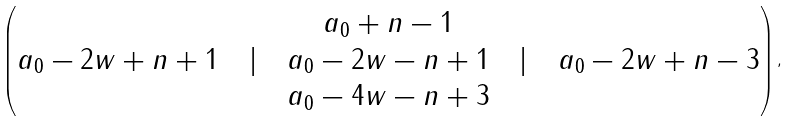Convert formula to latex. <formula><loc_0><loc_0><loc_500><loc_500>\begin{pmatrix} a _ { 0 } + n - 1 \\ a _ { 0 } - 2 w + n + 1 \quad | \quad a _ { 0 } - 2 w - n + 1 \quad | \quad a _ { 0 } - 2 w + n - 3 \\ a _ { 0 } - 4 w - n + 3 \end{pmatrix} ,</formula> 